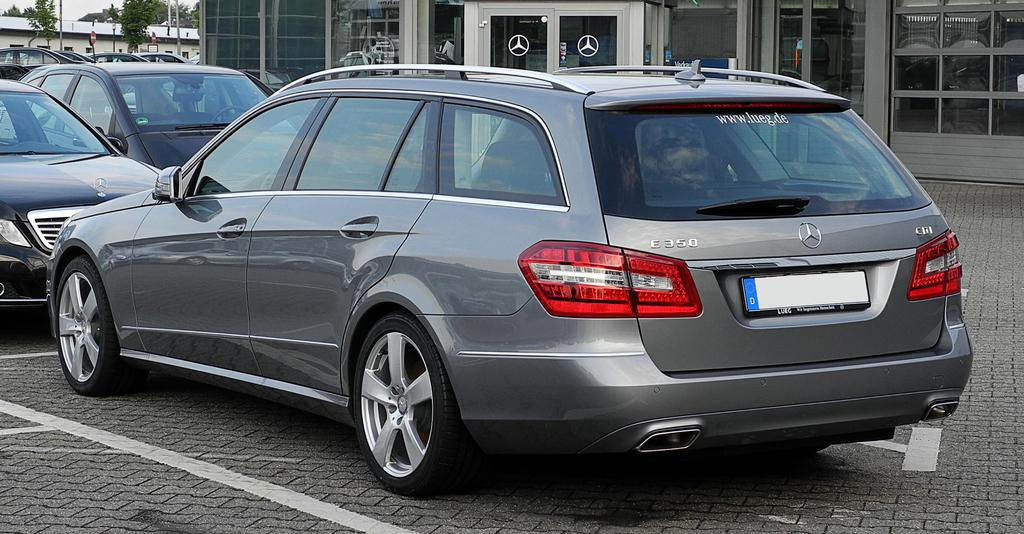What can be seen parked in the image? There are cars parked in the image. What type of structures are visible in the image? There are buildings visible in the image. What type of vegetation is present in the image? There are trees in the image. What type of informational displays can be seen in the image? There are sign boards in the image. What type of pan is being used to cook food in the image? There is no pan or cooking activity present in the image. How does the wind affect the trees in the image? The image does not show any movement of the trees, so it is not possible to determine the effect of the wind on them. 